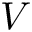Convert formula to latex. <formula><loc_0><loc_0><loc_500><loc_500>V</formula> 